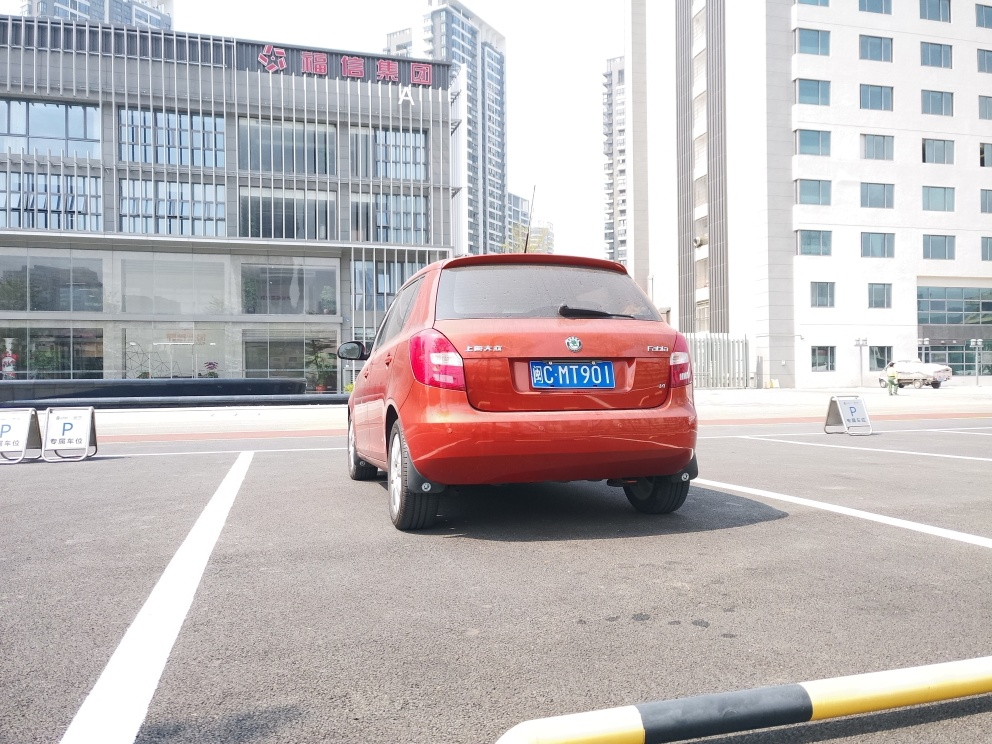Is there any indication of the time of day this photo was taken? While the image does not provide a direct indication of the precise time, there are several clues that suggest it was taken during daylight hours. The shadows cast by the car and the buildings are definitive, but not long or distorted, indicating that the sun is neither at a very low angle of morning or evening nor at its peak at midday. The bright and clear sky also contributes to the assessment that it is likely late morning or early afternoon. However, the absence of clocks or people that could provide additional context means we cannot determine the time with complete accuracy. 